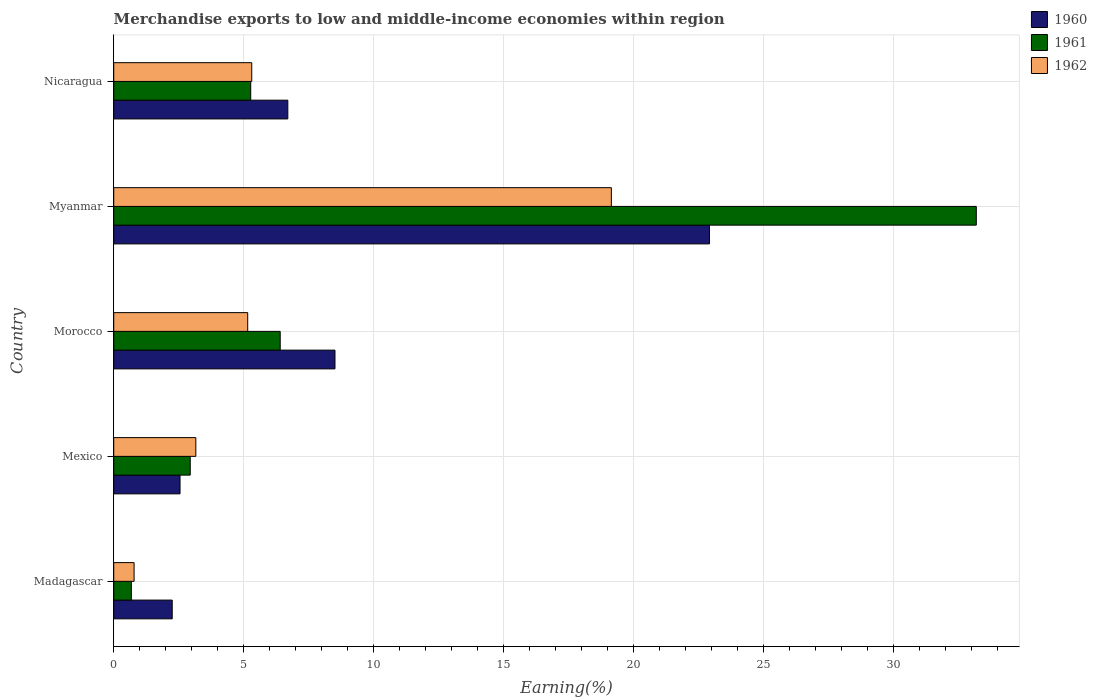Are the number of bars per tick equal to the number of legend labels?
Keep it short and to the point. Yes. How many bars are there on the 5th tick from the top?
Make the answer very short. 3. How many bars are there on the 4th tick from the bottom?
Provide a succinct answer. 3. What is the label of the 4th group of bars from the top?
Your response must be concise. Mexico. In how many cases, is the number of bars for a given country not equal to the number of legend labels?
Keep it short and to the point. 0. What is the percentage of amount earned from merchandise exports in 1962 in Myanmar?
Give a very brief answer. 19.15. Across all countries, what is the maximum percentage of amount earned from merchandise exports in 1960?
Your response must be concise. 22.92. Across all countries, what is the minimum percentage of amount earned from merchandise exports in 1961?
Provide a short and direct response. 0.68. In which country was the percentage of amount earned from merchandise exports in 1960 maximum?
Your response must be concise. Myanmar. In which country was the percentage of amount earned from merchandise exports in 1960 minimum?
Offer a terse response. Madagascar. What is the total percentage of amount earned from merchandise exports in 1961 in the graph?
Your answer should be compact. 48.49. What is the difference between the percentage of amount earned from merchandise exports in 1962 in Mexico and that in Morocco?
Provide a succinct answer. -2. What is the difference between the percentage of amount earned from merchandise exports in 1960 in Mexico and the percentage of amount earned from merchandise exports in 1961 in Madagascar?
Your response must be concise. 1.87. What is the average percentage of amount earned from merchandise exports in 1962 per country?
Ensure brevity in your answer.  6.71. What is the difference between the percentage of amount earned from merchandise exports in 1961 and percentage of amount earned from merchandise exports in 1962 in Madagascar?
Offer a terse response. -0.11. In how many countries, is the percentage of amount earned from merchandise exports in 1962 greater than 26 %?
Your answer should be very brief. 0. What is the ratio of the percentage of amount earned from merchandise exports in 1960 in Madagascar to that in Mexico?
Your response must be concise. 0.88. Is the percentage of amount earned from merchandise exports in 1961 in Mexico less than that in Myanmar?
Provide a succinct answer. Yes. Is the difference between the percentage of amount earned from merchandise exports in 1961 in Madagascar and Mexico greater than the difference between the percentage of amount earned from merchandise exports in 1962 in Madagascar and Mexico?
Your answer should be compact. Yes. What is the difference between the highest and the second highest percentage of amount earned from merchandise exports in 1962?
Provide a short and direct response. 13.84. What is the difference between the highest and the lowest percentage of amount earned from merchandise exports in 1961?
Provide a succinct answer. 32.51. What does the 1st bar from the bottom in Mexico represents?
Offer a terse response. 1960. Are all the bars in the graph horizontal?
Provide a short and direct response. Yes. Does the graph contain any zero values?
Make the answer very short. No. How many legend labels are there?
Keep it short and to the point. 3. What is the title of the graph?
Your answer should be compact. Merchandise exports to low and middle-income economies within region. Does "1962" appear as one of the legend labels in the graph?
Your answer should be compact. Yes. What is the label or title of the X-axis?
Your answer should be very brief. Earning(%). What is the label or title of the Y-axis?
Give a very brief answer. Country. What is the Earning(%) of 1960 in Madagascar?
Offer a terse response. 2.25. What is the Earning(%) in 1961 in Madagascar?
Your answer should be compact. 0.68. What is the Earning(%) of 1962 in Madagascar?
Give a very brief answer. 0.78. What is the Earning(%) in 1960 in Mexico?
Your answer should be very brief. 2.55. What is the Earning(%) in 1961 in Mexico?
Provide a short and direct response. 2.94. What is the Earning(%) in 1962 in Mexico?
Provide a succinct answer. 3.16. What is the Earning(%) in 1960 in Morocco?
Your answer should be very brief. 8.51. What is the Earning(%) of 1961 in Morocco?
Your answer should be very brief. 6.41. What is the Earning(%) of 1962 in Morocco?
Offer a very short reply. 5.15. What is the Earning(%) in 1960 in Myanmar?
Provide a short and direct response. 22.92. What is the Earning(%) of 1961 in Myanmar?
Your response must be concise. 33.19. What is the Earning(%) of 1962 in Myanmar?
Keep it short and to the point. 19.15. What is the Earning(%) of 1960 in Nicaragua?
Make the answer very short. 6.7. What is the Earning(%) in 1961 in Nicaragua?
Keep it short and to the point. 5.27. What is the Earning(%) in 1962 in Nicaragua?
Give a very brief answer. 5.31. Across all countries, what is the maximum Earning(%) of 1960?
Make the answer very short. 22.92. Across all countries, what is the maximum Earning(%) of 1961?
Your response must be concise. 33.19. Across all countries, what is the maximum Earning(%) in 1962?
Your answer should be very brief. 19.15. Across all countries, what is the minimum Earning(%) in 1960?
Keep it short and to the point. 2.25. Across all countries, what is the minimum Earning(%) of 1961?
Your response must be concise. 0.68. Across all countries, what is the minimum Earning(%) of 1962?
Your response must be concise. 0.78. What is the total Earning(%) in 1960 in the graph?
Provide a succinct answer. 42.94. What is the total Earning(%) of 1961 in the graph?
Your response must be concise. 48.49. What is the total Earning(%) in 1962 in the graph?
Your response must be concise. 33.55. What is the difference between the Earning(%) of 1960 in Madagascar and that in Mexico?
Offer a very short reply. -0.3. What is the difference between the Earning(%) of 1961 in Madagascar and that in Mexico?
Provide a succinct answer. -2.27. What is the difference between the Earning(%) of 1962 in Madagascar and that in Mexico?
Provide a succinct answer. -2.38. What is the difference between the Earning(%) in 1960 in Madagascar and that in Morocco?
Make the answer very short. -6.26. What is the difference between the Earning(%) of 1961 in Madagascar and that in Morocco?
Make the answer very short. -5.73. What is the difference between the Earning(%) in 1962 in Madagascar and that in Morocco?
Ensure brevity in your answer.  -4.37. What is the difference between the Earning(%) of 1960 in Madagascar and that in Myanmar?
Offer a very short reply. -20.67. What is the difference between the Earning(%) in 1961 in Madagascar and that in Myanmar?
Your response must be concise. -32.51. What is the difference between the Earning(%) of 1962 in Madagascar and that in Myanmar?
Keep it short and to the point. -18.37. What is the difference between the Earning(%) of 1960 in Madagascar and that in Nicaragua?
Make the answer very short. -4.45. What is the difference between the Earning(%) of 1961 in Madagascar and that in Nicaragua?
Your answer should be very brief. -4.59. What is the difference between the Earning(%) of 1962 in Madagascar and that in Nicaragua?
Your response must be concise. -4.53. What is the difference between the Earning(%) of 1960 in Mexico and that in Morocco?
Provide a short and direct response. -5.96. What is the difference between the Earning(%) in 1961 in Mexico and that in Morocco?
Give a very brief answer. -3.46. What is the difference between the Earning(%) of 1962 in Mexico and that in Morocco?
Keep it short and to the point. -2. What is the difference between the Earning(%) of 1960 in Mexico and that in Myanmar?
Provide a succinct answer. -20.37. What is the difference between the Earning(%) of 1961 in Mexico and that in Myanmar?
Your answer should be very brief. -30.25. What is the difference between the Earning(%) of 1962 in Mexico and that in Myanmar?
Provide a short and direct response. -15.99. What is the difference between the Earning(%) of 1960 in Mexico and that in Nicaragua?
Your answer should be compact. -4.15. What is the difference between the Earning(%) of 1961 in Mexico and that in Nicaragua?
Your answer should be very brief. -2.33. What is the difference between the Earning(%) in 1962 in Mexico and that in Nicaragua?
Your answer should be compact. -2.15. What is the difference between the Earning(%) of 1960 in Morocco and that in Myanmar?
Your answer should be very brief. -14.41. What is the difference between the Earning(%) in 1961 in Morocco and that in Myanmar?
Offer a very short reply. -26.79. What is the difference between the Earning(%) of 1962 in Morocco and that in Myanmar?
Make the answer very short. -13.99. What is the difference between the Earning(%) of 1960 in Morocco and that in Nicaragua?
Ensure brevity in your answer.  1.81. What is the difference between the Earning(%) in 1961 in Morocco and that in Nicaragua?
Ensure brevity in your answer.  1.13. What is the difference between the Earning(%) in 1962 in Morocco and that in Nicaragua?
Your answer should be compact. -0.15. What is the difference between the Earning(%) in 1960 in Myanmar and that in Nicaragua?
Give a very brief answer. 16.22. What is the difference between the Earning(%) of 1961 in Myanmar and that in Nicaragua?
Offer a terse response. 27.92. What is the difference between the Earning(%) in 1962 in Myanmar and that in Nicaragua?
Provide a succinct answer. 13.84. What is the difference between the Earning(%) in 1960 in Madagascar and the Earning(%) in 1961 in Mexico?
Offer a very short reply. -0.69. What is the difference between the Earning(%) of 1960 in Madagascar and the Earning(%) of 1962 in Mexico?
Provide a short and direct response. -0.91. What is the difference between the Earning(%) of 1961 in Madagascar and the Earning(%) of 1962 in Mexico?
Ensure brevity in your answer.  -2.48. What is the difference between the Earning(%) in 1960 in Madagascar and the Earning(%) in 1961 in Morocco?
Give a very brief answer. -4.16. What is the difference between the Earning(%) of 1960 in Madagascar and the Earning(%) of 1962 in Morocco?
Provide a succinct answer. -2.9. What is the difference between the Earning(%) in 1961 in Madagascar and the Earning(%) in 1962 in Morocco?
Give a very brief answer. -4.48. What is the difference between the Earning(%) of 1960 in Madagascar and the Earning(%) of 1961 in Myanmar?
Give a very brief answer. -30.94. What is the difference between the Earning(%) of 1960 in Madagascar and the Earning(%) of 1962 in Myanmar?
Your answer should be compact. -16.9. What is the difference between the Earning(%) of 1961 in Madagascar and the Earning(%) of 1962 in Myanmar?
Make the answer very short. -18.47. What is the difference between the Earning(%) in 1960 in Madagascar and the Earning(%) in 1961 in Nicaragua?
Make the answer very short. -3.02. What is the difference between the Earning(%) of 1960 in Madagascar and the Earning(%) of 1962 in Nicaragua?
Offer a terse response. -3.06. What is the difference between the Earning(%) in 1961 in Madagascar and the Earning(%) in 1962 in Nicaragua?
Your answer should be very brief. -4.63. What is the difference between the Earning(%) of 1960 in Mexico and the Earning(%) of 1961 in Morocco?
Provide a short and direct response. -3.85. What is the difference between the Earning(%) in 1960 in Mexico and the Earning(%) in 1962 in Morocco?
Make the answer very short. -2.6. What is the difference between the Earning(%) of 1961 in Mexico and the Earning(%) of 1962 in Morocco?
Provide a short and direct response. -2.21. What is the difference between the Earning(%) in 1960 in Mexico and the Earning(%) in 1961 in Myanmar?
Offer a very short reply. -30.64. What is the difference between the Earning(%) of 1960 in Mexico and the Earning(%) of 1962 in Myanmar?
Give a very brief answer. -16.6. What is the difference between the Earning(%) of 1961 in Mexico and the Earning(%) of 1962 in Myanmar?
Offer a terse response. -16.2. What is the difference between the Earning(%) in 1960 in Mexico and the Earning(%) in 1961 in Nicaragua?
Make the answer very short. -2.72. What is the difference between the Earning(%) of 1960 in Mexico and the Earning(%) of 1962 in Nicaragua?
Give a very brief answer. -2.76. What is the difference between the Earning(%) of 1961 in Mexico and the Earning(%) of 1962 in Nicaragua?
Provide a short and direct response. -2.37. What is the difference between the Earning(%) in 1960 in Morocco and the Earning(%) in 1961 in Myanmar?
Keep it short and to the point. -24.68. What is the difference between the Earning(%) in 1960 in Morocco and the Earning(%) in 1962 in Myanmar?
Offer a very short reply. -10.63. What is the difference between the Earning(%) in 1961 in Morocco and the Earning(%) in 1962 in Myanmar?
Offer a terse response. -12.74. What is the difference between the Earning(%) in 1960 in Morocco and the Earning(%) in 1961 in Nicaragua?
Ensure brevity in your answer.  3.24. What is the difference between the Earning(%) of 1960 in Morocco and the Earning(%) of 1962 in Nicaragua?
Make the answer very short. 3.2. What is the difference between the Earning(%) in 1961 in Morocco and the Earning(%) in 1962 in Nicaragua?
Offer a terse response. 1.1. What is the difference between the Earning(%) in 1960 in Myanmar and the Earning(%) in 1961 in Nicaragua?
Offer a very short reply. 17.65. What is the difference between the Earning(%) in 1960 in Myanmar and the Earning(%) in 1962 in Nicaragua?
Ensure brevity in your answer.  17.61. What is the difference between the Earning(%) in 1961 in Myanmar and the Earning(%) in 1962 in Nicaragua?
Keep it short and to the point. 27.88. What is the average Earning(%) in 1960 per country?
Ensure brevity in your answer.  8.59. What is the average Earning(%) of 1961 per country?
Ensure brevity in your answer.  9.7. What is the average Earning(%) of 1962 per country?
Your answer should be very brief. 6.71. What is the difference between the Earning(%) of 1960 and Earning(%) of 1961 in Madagascar?
Provide a succinct answer. 1.57. What is the difference between the Earning(%) in 1960 and Earning(%) in 1962 in Madagascar?
Make the answer very short. 1.47. What is the difference between the Earning(%) in 1961 and Earning(%) in 1962 in Madagascar?
Ensure brevity in your answer.  -0.11. What is the difference between the Earning(%) in 1960 and Earning(%) in 1961 in Mexico?
Your answer should be very brief. -0.39. What is the difference between the Earning(%) of 1960 and Earning(%) of 1962 in Mexico?
Your answer should be very brief. -0.61. What is the difference between the Earning(%) in 1961 and Earning(%) in 1962 in Mexico?
Offer a terse response. -0.22. What is the difference between the Earning(%) in 1960 and Earning(%) in 1961 in Morocco?
Offer a very short reply. 2.11. What is the difference between the Earning(%) of 1960 and Earning(%) of 1962 in Morocco?
Keep it short and to the point. 3.36. What is the difference between the Earning(%) in 1961 and Earning(%) in 1962 in Morocco?
Provide a succinct answer. 1.25. What is the difference between the Earning(%) in 1960 and Earning(%) in 1961 in Myanmar?
Offer a very short reply. -10.27. What is the difference between the Earning(%) in 1960 and Earning(%) in 1962 in Myanmar?
Offer a terse response. 3.78. What is the difference between the Earning(%) in 1961 and Earning(%) in 1962 in Myanmar?
Offer a terse response. 14.04. What is the difference between the Earning(%) in 1960 and Earning(%) in 1961 in Nicaragua?
Your answer should be compact. 1.43. What is the difference between the Earning(%) of 1960 and Earning(%) of 1962 in Nicaragua?
Provide a succinct answer. 1.39. What is the difference between the Earning(%) of 1961 and Earning(%) of 1962 in Nicaragua?
Make the answer very short. -0.04. What is the ratio of the Earning(%) of 1960 in Madagascar to that in Mexico?
Provide a succinct answer. 0.88. What is the ratio of the Earning(%) of 1961 in Madagascar to that in Mexico?
Make the answer very short. 0.23. What is the ratio of the Earning(%) of 1962 in Madagascar to that in Mexico?
Give a very brief answer. 0.25. What is the ratio of the Earning(%) of 1960 in Madagascar to that in Morocco?
Offer a very short reply. 0.26. What is the ratio of the Earning(%) of 1961 in Madagascar to that in Morocco?
Keep it short and to the point. 0.11. What is the ratio of the Earning(%) in 1962 in Madagascar to that in Morocco?
Your answer should be compact. 0.15. What is the ratio of the Earning(%) in 1960 in Madagascar to that in Myanmar?
Keep it short and to the point. 0.1. What is the ratio of the Earning(%) of 1961 in Madagascar to that in Myanmar?
Ensure brevity in your answer.  0.02. What is the ratio of the Earning(%) of 1962 in Madagascar to that in Myanmar?
Give a very brief answer. 0.04. What is the ratio of the Earning(%) in 1960 in Madagascar to that in Nicaragua?
Ensure brevity in your answer.  0.34. What is the ratio of the Earning(%) of 1961 in Madagascar to that in Nicaragua?
Your answer should be very brief. 0.13. What is the ratio of the Earning(%) of 1962 in Madagascar to that in Nicaragua?
Your answer should be very brief. 0.15. What is the ratio of the Earning(%) in 1960 in Mexico to that in Morocco?
Your answer should be compact. 0.3. What is the ratio of the Earning(%) of 1961 in Mexico to that in Morocco?
Your answer should be very brief. 0.46. What is the ratio of the Earning(%) of 1962 in Mexico to that in Morocco?
Offer a very short reply. 0.61. What is the ratio of the Earning(%) in 1960 in Mexico to that in Myanmar?
Ensure brevity in your answer.  0.11. What is the ratio of the Earning(%) in 1961 in Mexico to that in Myanmar?
Provide a short and direct response. 0.09. What is the ratio of the Earning(%) of 1962 in Mexico to that in Myanmar?
Provide a short and direct response. 0.17. What is the ratio of the Earning(%) in 1960 in Mexico to that in Nicaragua?
Offer a terse response. 0.38. What is the ratio of the Earning(%) of 1961 in Mexico to that in Nicaragua?
Your answer should be very brief. 0.56. What is the ratio of the Earning(%) of 1962 in Mexico to that in Nicaragua?
Give a very brief answer. 0.59. What is the ratio of the Earning(%) of 1960 in Morocco to that in Myanmar?
Provide a short and direct response. 0.37. What is the ratio of the Earning(%) of 1961 in Morocco to that in Myanmar?
Make the answer very short. 0.19. What is the ratio of the Earning(%) of 1962 in Morocco to that in Myanmar?
Your response must be concise. 0.27. What is the ratio of the Earning(%) of 1960 in Morocco to that in Nicaragua?
Give a very brief answer. 1.27. What is the ratio of the Earning(%) in 1961 in Morocco to that in Nicaragua?
Provide a short and direct response. 1.22. What is the ratio of the Earning(%) in 1962 in Morocco to that in Nicaragua?
Your response must be concise. 0.97. What is the ratio of the Earning(%) in 1960 in Myanmar to that in Nicaragua?
Provide a succinct answer. 3.42. What is the ratio of the Earning(%) of 1961 in Myanmar to that in Nicaragua?
Your response must be concise. 6.3. What is the ratio of the Earning(%) of 1962 in Myanmar to that in Nicaragua?
Offer a terse response. 3.61. What is the difference between the highest and the second highest Earning(%) in 1960?
Offer a very short reply. 14.41. What is the difference between the highest and the second highest Earning(%) in 1961?
Offer a terse response. 26.79. What is the difference between the highest and the second highest Earning(%) in 1962?
Keep it short and to the point. 13.84. What is the difference between the highest and the lowest Earning(%) of 1960?
Give a very brief answer. 20.67. What is the difference between the highest and the lowest Earning(%) of 1961?
Offer a terse response. 32.51. What is the difference between the highest and the lowest Earning(%) in 1962?
Your answer should be very brief. 18.37. 